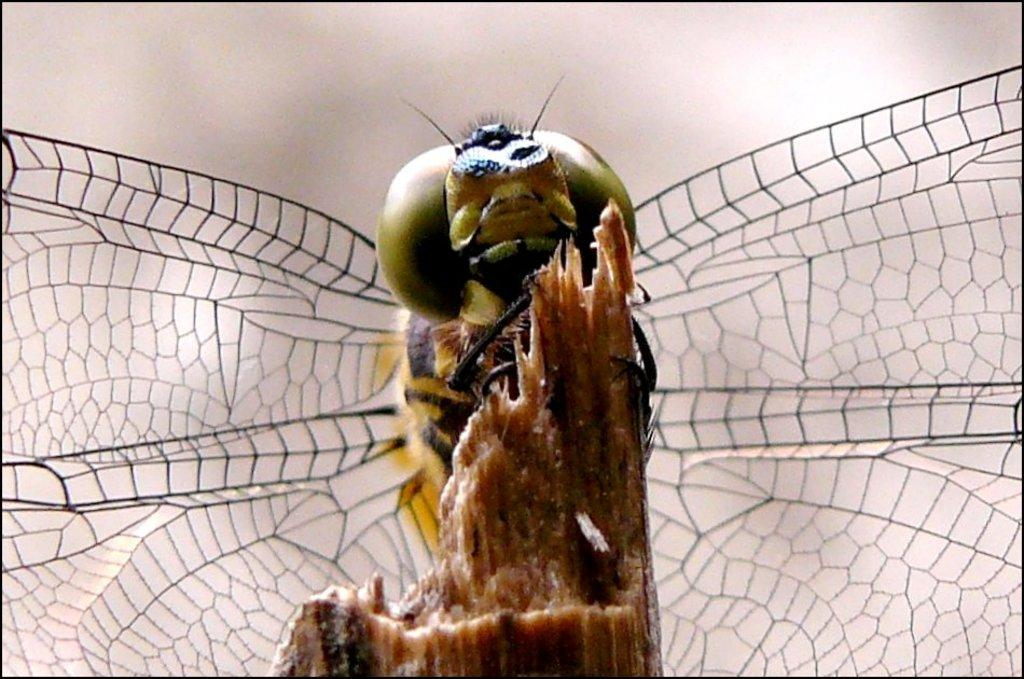What is the main subject of the picture? The main subject of the picture is an insect. Where is the insect located in the image? The insect is on a wooden surface. Can you describe the background of the image? The background of the image is blurred. What type of prose can be heard in the background of the image? There is no prose or sound present in the image, as it is a still photograph featuring an insect on a wooden surface with a blurred background. 